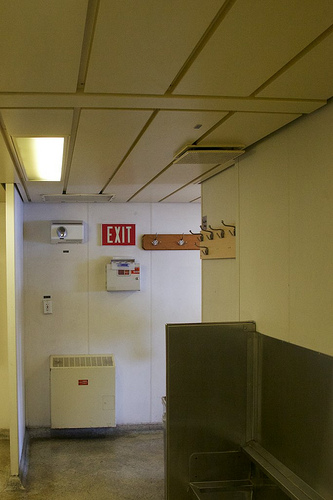<image>
Is there a light in the roof? Yes. The light is contained within or inside the roof, showing a containment relationship. 